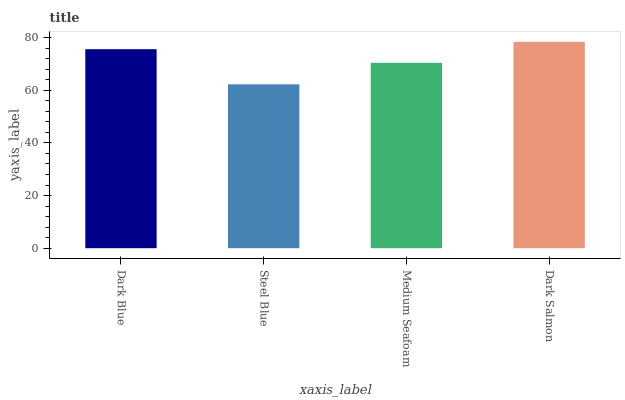Is Steel Blue the minimum?
Answer yes or no. Yes. Is Dark Salmon the maximum?
Answer yes or no. Yes. Is Medium Seafoam the minimum?
Answer yes or no. No. Is Medium Seafoam the maximum?
Answer yes or no. No. Is Medium Seafoam greater than Steel Blue?
Answer yes or no. Yes. Is Steel Blue less than Medium Seafoam?
Answer yes or no. Yes. Is Steel Blue greater than Medium Seafoam?
Answer yes or no. No. Is Medium Seafoam less than Steel Blue?
Answer yes or no. No. Is Dark Blue the high median?
Answer yes or no. Yes. Is Medium Seafoam the low median?
Answer yes or no. Yes. Is Medium Seafoam the high median?
Answer yes or no. No. Is Dark Salmon the low median?
Answer yes or no. No. 